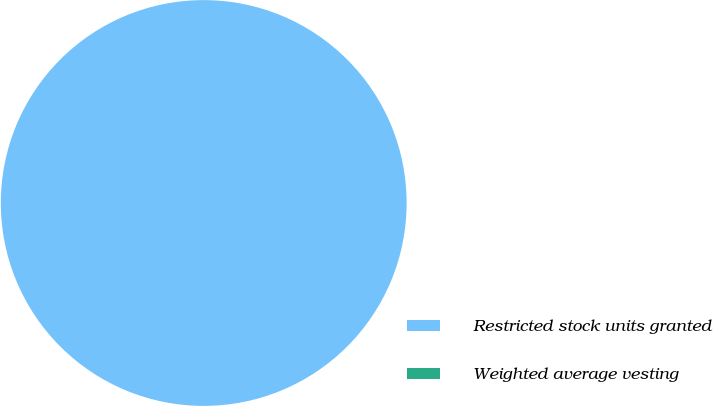Convert chart. <chart><loc_0><loc_0><loc_500><loc_500><pie_chart><fcel>Restricted stock units granted<fcel>Weighted average vesting<nl><fcel>100.0%<fcel>0.0%<nl></chart> 